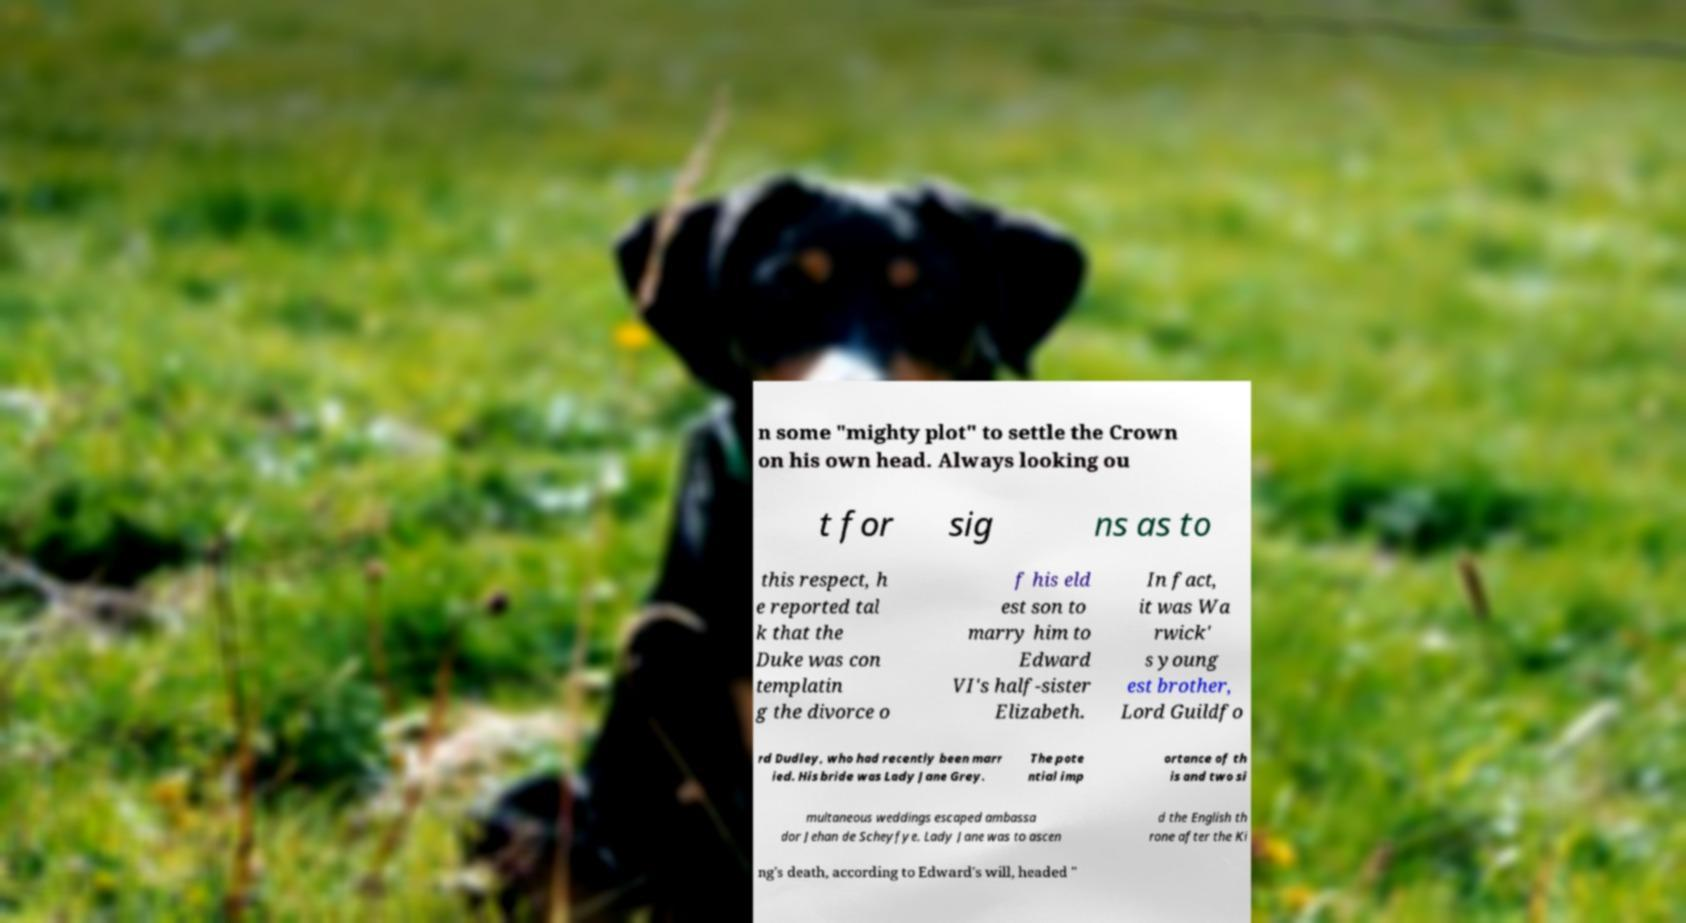There's text embedded in this image that I need extracted. Can you transcribe it verbatim? n some "mighty plot" to settle the Crown on his own head. Always looking ou t for sig ns as to this respect, h e reported tal k that the Duke was con templatin g the divorce o f his eld est son to marry him to Edward VI's half-sister Elizabeth. In fact, it was Wa rwick' s young est brother, Lord Guildfo rd Dudley, who had recently been marr ied. His bride was Lady Jane Grey. The pote ntial imp ortance of th is and two si multaneous weddings escaped ambassa dor Jehan de Scheyfye. Lady Jane was to ascen d the English th rone after the Ki ng's death, according to Edward's will, headed " 